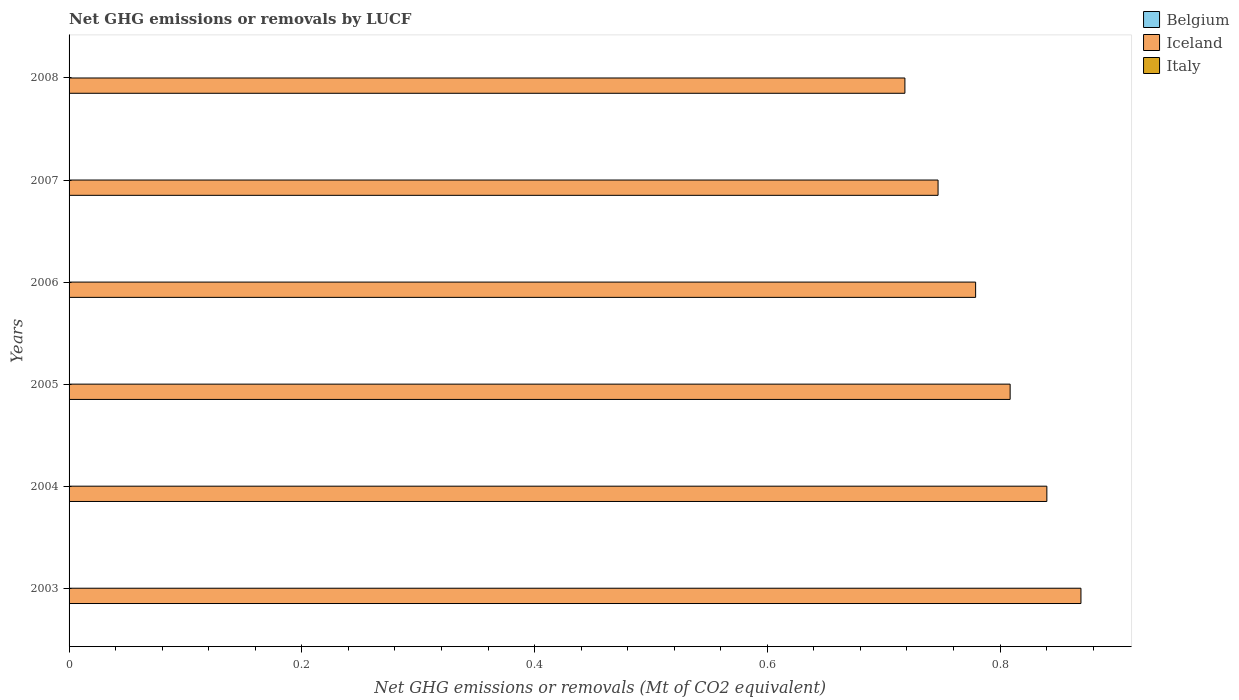How many different coloured bars are there?
Your answer should be very brief. 1. How many bars are there on the 3rd tick from the top?
Offer a very short reply. 1. How many bars are there on the 3rd tick from the bottom?
Ensure brevity in your answer.  1. Across all years, what is the maximum net GHG emissions or removals by LUCF in Iceland?
Your answer should be very brief. 0.87. Across all years, what is the minimum net GHG emissions or removals by LUCF in Belgium?
Provide a succinct answer. 0. What is the difference between the net GHG emissions or removals by LUCF in Iceland in 2003 and that in 2005?
Offer a very short reply. 0.06. What is the difference between the net GHG emissions or removals by LUCF in Iceland in 2005 and the net GHG emissions or removals by LUCF in Belgium in 2007?
Give a very brief answer. 0.81. What is the difference between the highest and the second highest net GHG emissions or removals by LUCF in Iceland?
Offer a terse response. 0.03. What is the difference between the highest and the lowest net GHG emissions or removals by LUCF in Iceland?
Your answer should be compact. 0.15. In how many years, is the net GHG emissions or removals by LUCF in Iceland greater than the average net GHG emissions or removals by LUCF in Iceland taken over all years?
Offer a very short reply. 3. Is it the case that in every year, the sum of the net GHG emissions or removals by LUCF in Iceland and net GHG emissions or removals by LUCF in Belgium is greater than the net GHG emissions or removals by LUCF in Italy?
Ensure brevity in your answer.  Yes. How many bars are there?
Provide a succinct answer. 6. Are the values on the major ticks of X-axis written in scientific E-notation?
Offer a very short reply. No. Does the graph contain any zero values?
Offer a terse response. Yes. What is the title of the graph?
Your answer should be compact. Net GHG emissions or removals by LUCF. Does "Mauritius" appear as one of the legend labels in the graph?
Make the answer very short. No. What is the label or title of the X-axis?
Keep it short and to the point. Net GHG emissions or removals (Mt of CO2 equivalent). What is the Net GHG emissions or removals (Mt of CO2 equivalent) of Belgium in 2003?
Provide a succinct answer. 0. What is the Net GHG emissions or removals (Mt of CO2 equivalent) in Iceland in 2003?
Your answer should be compact. 0.87. What is the Net GHG emissions or removals (Mt of CO2 equivalent) in Italy in 2003?
Offer a terse response. 0. What is the Net GHG emissions or removals (Mt of CO2 equivalent) of Iceland in 2004?
Provide a short and direct response. 0.84. What is the Net GHG emissions or removals (Mt of CO2 equivalent) in Italy in 2004?
Offer a terse response. 0. What is the Net GHG emissions or removals (Mt of CO2 equivalent) of Iceland in 2005?
Make the answer very short. 0.81. What is the Net GHG emissions or removals (Mt of CO2 equivalent) of Italy in 2005?
Ensure brevity in your answer.  0. What is the Net GHG emissions or removals (Mt of CO2 equivalent) of Belgium in 2006?
Give a very brief answer. 0. What is the Net GHG emissions or removals (Mt of CO2 equivalent) of Iceland in 2006?
Provide a succinct answer. 0.78. What is the Net GHG emissions or removals (Mt of CO2 equivalent) in Italy in 2006?
Offer a terse response. 0. What is the Net GHG emissions or removals (Mt of CO2 equivalent) in Iceland in 2007?
Your answer should be compact. 0.75. What is the Net GHG emissions or removals (Mt of CO2 equivalent) of Belgium in 2008?
Your answer should be compact. 0. What is the Net GHG emissions or removals (Mt of CO2 equivalent) of Iceland in 2008?
Offer a very short reply. 0.72. Across all years, what is the maximum Net GHG emissions or removals (Mt of CO2 equivalent) in Iceland?
Offer a very short reply. 0.87. Across all years, what is the minimum Net GHG emissions or removals (Mt of CO2 equivalent) in Iceland?
Make the answer very short. 0.72. What is the total Net GHG emissions or removals (Mt of CO2 equivalent) in Belgium in the graph?
Your answer should be very brief. 0. What is the total Net GHG emissions or removals (Mt of CO2 equivalent) of Iceland in the graph?
Keep it short and to the point. 4.76. What is the difference between the Net GHG emissions or removals (Mt of CO2 equivalent) in Iceland in 2003 and that in 2004?
Offer a terse response. 0.03. What is the difference between the Net GHG emissions or removals (Mt of CO2 equivalent) in Iceland in 2003 and that in 2005?
Provide a succinct answer. 0.06. What is the difference between the Net GHG emissions or removals (Mt of CO2 equivalent) in Iceland in 2003 and that in 2006?
Ensure brevity in your answer.  0.09. What is the difference between the Net GHG emissions or removals (Mt of CO2 equivalent) in Iceland in 2003 and that in 2007?
Provide a short and direct response. 0.12. What is the difference between the Net GHG emissions or removals (Mt of CO2 equivalent) of Iceland in 2003 and that in 2008?
Provide a succinct answer. 0.15. What is the difference between the Net GHG emissions or removals (Mt of CO2 equivalent) in Iceland in 2004 and that in 2005?
Offer a terse response. 0.03. What is the difference between the Net GHG emissions or removals (Mt of CO2 equivalent) in Iceland in 2004 and that in 2006?
Make the answer very short. 0.06. What is the difference between the Net GHG emissions or removals (Mt of CO2 equivalent) of Iceland in 2004 and that in 2007?
Provide a succinct answer. 0.09. What is the difference between the Net GHG emissions or removals (Mt of CO2 equivalent) of Iceland in 2004 and that in 2008?
Provide a short and direct response. 0.12. What is the difference between the Net GHG emissions or removals (Mt of CO2 equivalent) of Iceland in 2005 and that in 2006?
Make the answer very short. 0.03. What is the difference between the Net GHG emissions or removals (Mt of CO2 equivalent) of Iceland in 2005 and that in 2007?
Your answer should be compact. 0.06. What is the difference between the Net GHG emissions or removals (Mt of CO2 equivalent) in Iceland in 2005 and that in 2008?
Provide a succinct answer. 0.09. What is the difference between the Net GHG emissions or removals (Mt of CO2 equivalent) of Iceland in 2006 and that in 2007?
Your answer should be very brief. 0.03. What is the difference between the Net GHG emissions or removals (Mt of CO2 equivalent) of Iceland in 2006 and that in 2008?
Offer a very short reply. 0.06. What is the difference between the Net GHG emissions or removals (Mt of CO2 equivalent) in Iceland in 2007 and that in 2008?
Offer a very short reply. 0.03. What is the average Net GHG emissions or removals (Mt of CO2 equivalent) in Belgium per year?
Ensure brevity in your answer.  0. What is the average Net GHG emissions or removals (Mt of CO2 equivalent) in Iceland per year?
Provide a short and direct response. 0.79. What is the ratio of the Net GHG emissions or removals (Mt of CO2 equivalent) in Iceland in 2003 to that in 2004?
Offer a terse response. 1.03. What is the ratio of the Net GHG emissions or removals (Mt of CO2 equivalent) of Iceland in 2003 to that in 2005?
Provide a succinct answer. 1.08. What is the ratio of the Net GHG emissions or removals (Mt of CO2 equivalent) in Iceland in 2003 to that in 2006?
Offer a very short reply. 1.12. What is the ratio of the Net GHG emissions or removals (Mt of CO2 equivalent) in Iceland in 2003 to that in 2007?
Offer a very short reply. 1.16. What is the ratio of the Net GHG emissions or removals (Mt of CO2 equivalent) in Iceland in 2003 to that in 2008?
Make the answer very short. 1.21. What is the ratio of the Net GHG emissions or removals (Mt of CO2 equivalent) in Iceland in 2004 to that in 2005?
Offer a very short reply. 1.04. What is the ratio of the Net GHG emissions or removals (Mt of CO2 equivalent) in Iceland in 2004 to that in 2006?
Offer a very short reply. 1.08. What is the ratio of the Net GHG emissions or removals (Mt of CO2 equivalent) in Iceland in 2004 to that in 2007?
Offer a terse response. 1.13. What is the ratio of the Net GHG emissions or removals (Mt of CO2 equivalent) of Iceland in 2004 to that in 2008?
Make the answer very short. 1.17. What is the ratio of the Net GHG emissions or removals (Mt of CO2 equivalent) of Iceland in 2005 to that in 2006?
Make the answer very short. 1.04. What is the ratio of the Net GHG emissions or removals (Mt of CO2 equivalent) in Iceland in 2005 to that in 2007?
Make the answer very short. 1.08. What is the ratio of the Net GHG emissions or removals (Mt of CO2 equivalent) in Iceland in 2005 to that in 2008?
Make the answer very short. 1.13. What is the ratio of the Net GHG emissions or removals (Mt of CO2 equivalent) of Iceland in 2006 to that in 2007?
Provide a short and direct response. 1.04. What is the ratio of the Net GHG emissions or removals (Mt of CO2 equivalent) of Iceland in 2006 to that in 2008?
Ensure brevity in your answer.  1.08. What is the ratio of the Net GHG emissions or removals (Mt of CO2 equivalent) of Iceland in 2007 to that in 2008?
Offer a terse response. 1.04. What is the difference between the highest and the second highest Net GHG emissions or removals (Mt of CO2 equivalent) of Iceland?
Ensure brevity in your answer.  0.03. What is the difference between the highest and the lowest Net GHG emissions or removals (Mt of CO2 equivalent) in Iceland?
Make the answer very short. 0.15. 